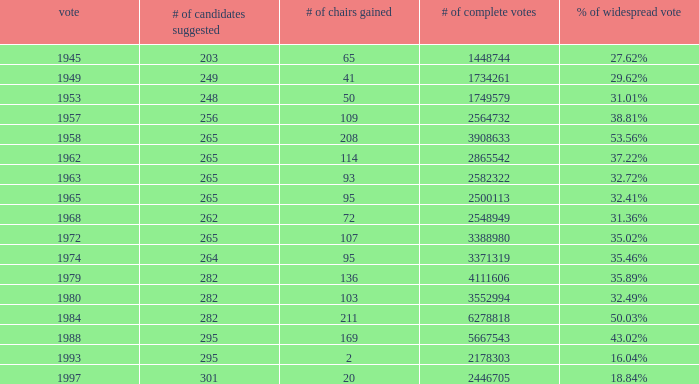What is the election year when the # of candidates nominated was 262? 1.0. 